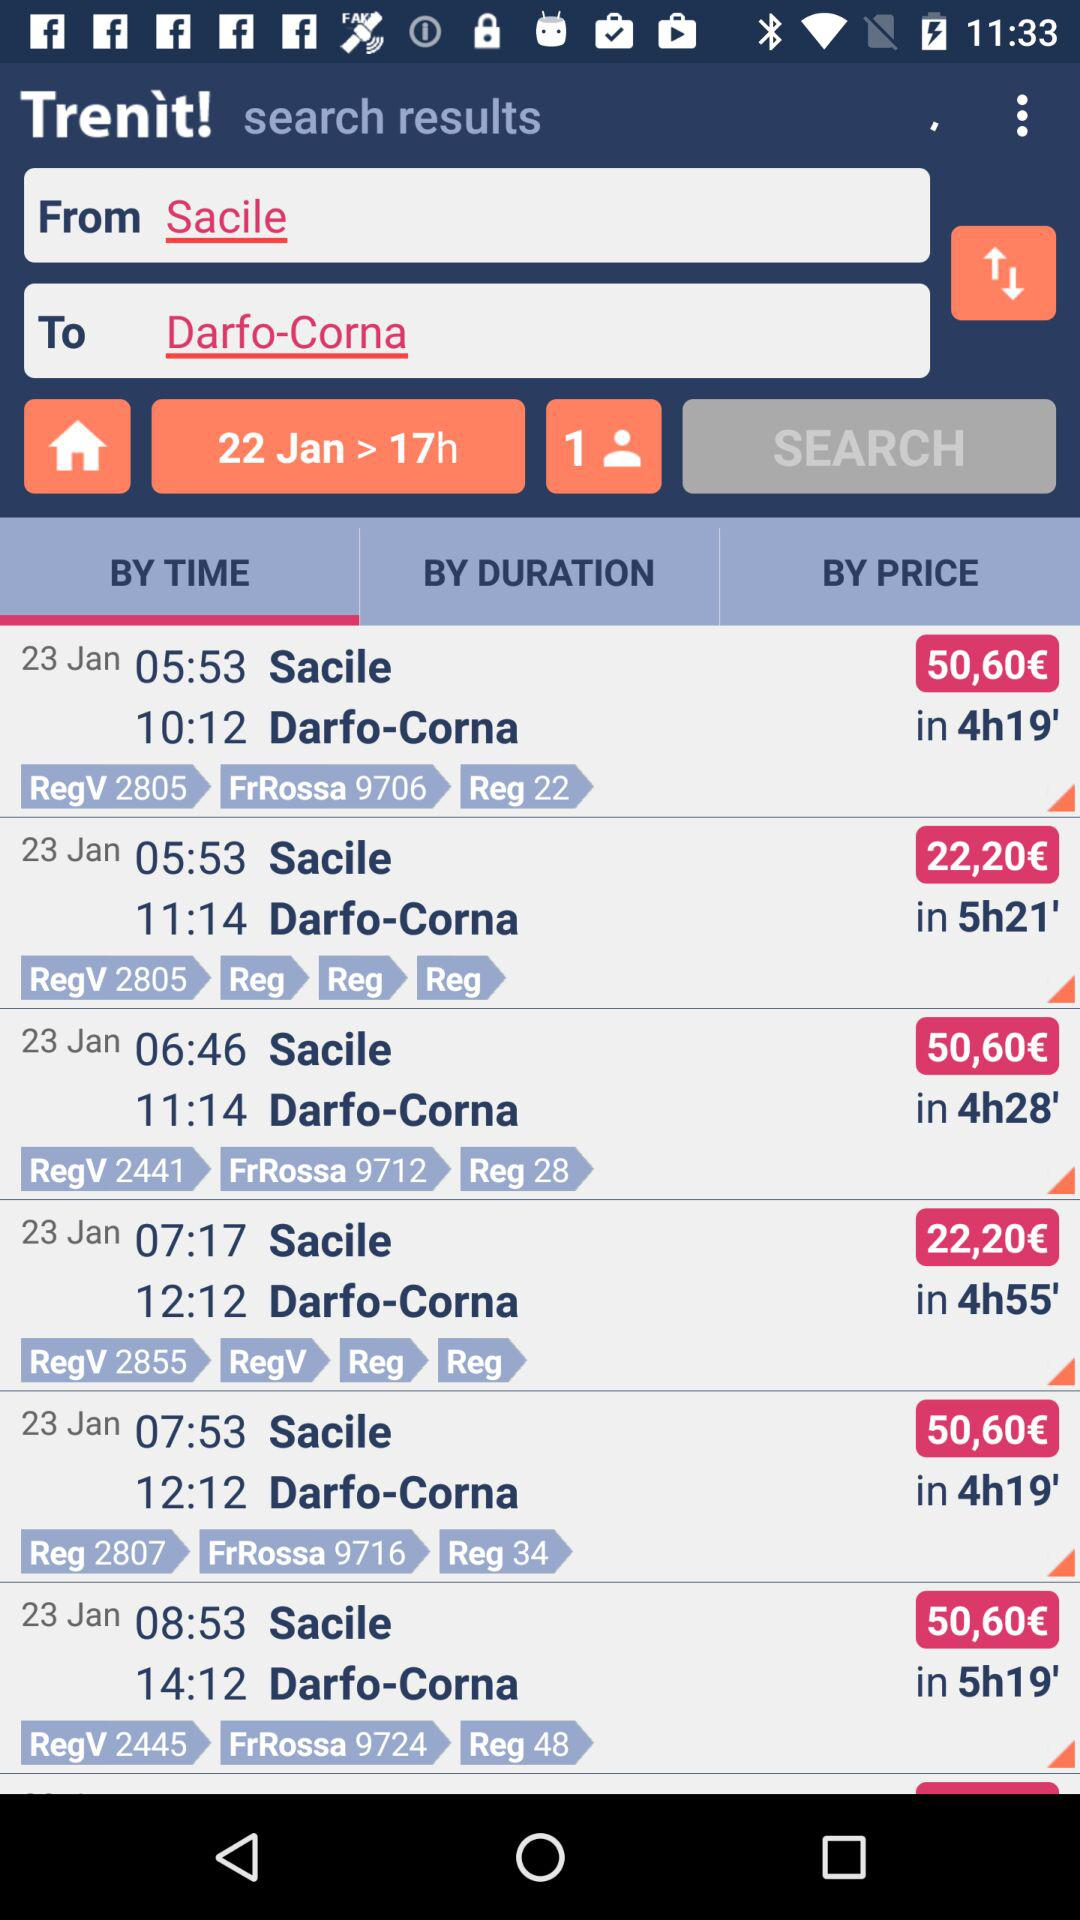What is the departure location? The departure location is Sacile. 